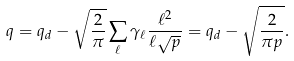Convert formula to latex. <formula><loc_0><loc_0><loc_500><loc_500>q = q _ { d } - \sqrt { \frac { 2 } { \pi } } \sum _ { \ell } \gamma _ { \ell } \frac { \ell ^ { 2 } } { \ell \sqrt { p } } = q _ { d } - \sqrt { \frac { 2 } { \pi p } } .</formula> 